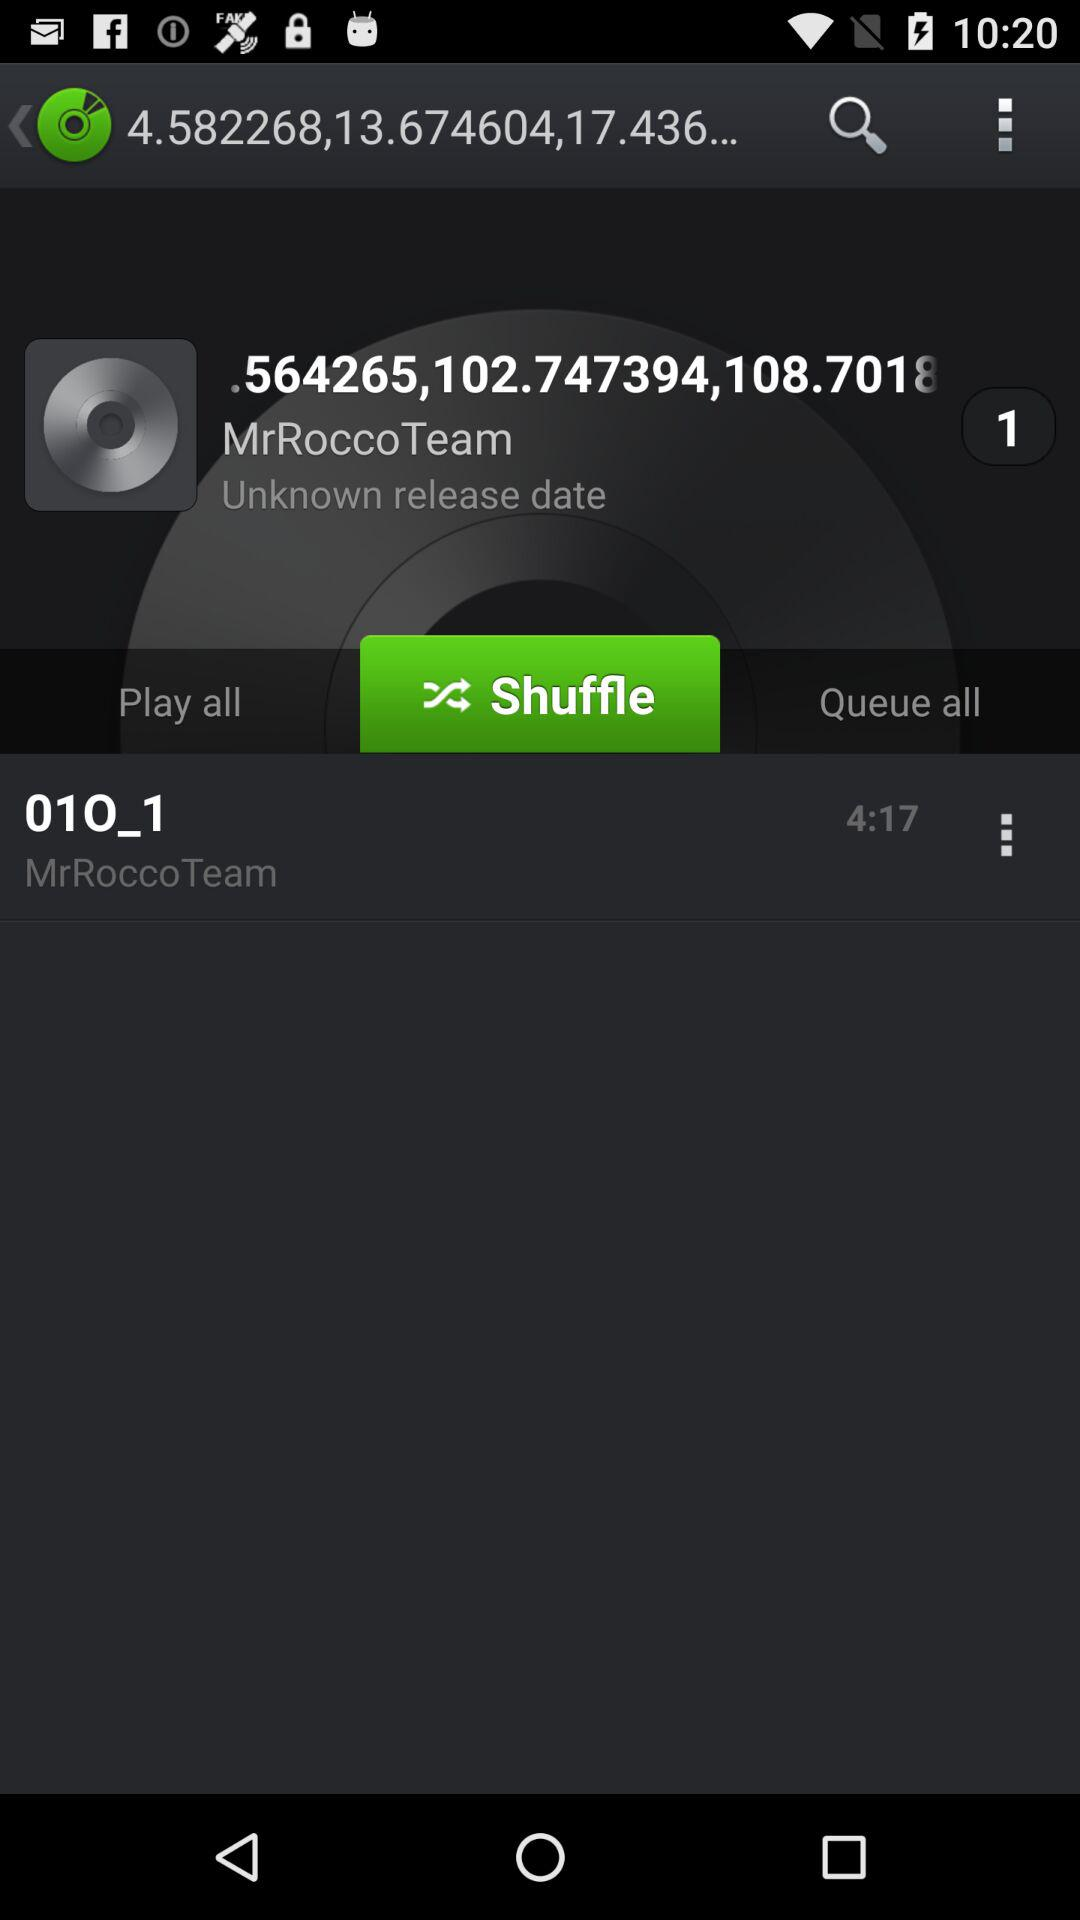Which tab is selected? The selected tab is "Shuffle". 